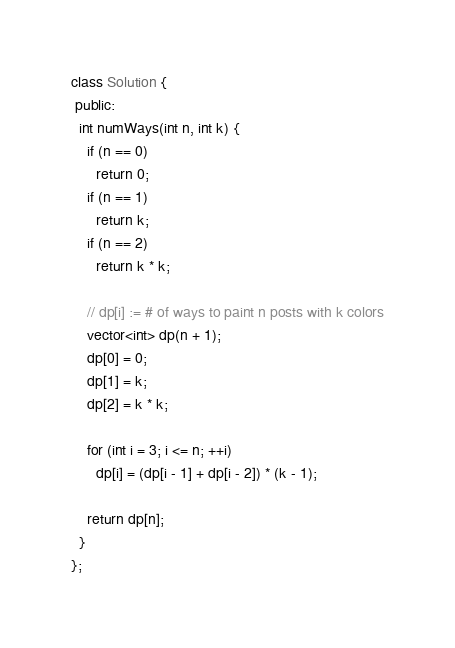<code> <loc_0><loc_0><loc_500><loc_500><_C++_>class Solution {
 public:
  int numWays(int n, int k) {
    if (n == 0)
      return 0;
    if (n == 1)
      return k;
    if (n == 2)
      return k * k;

    // dp[i] := # of ways to paint n posts with k colors
    vector<int> dp(n + 1);
    dp[0] = 0;
    dp[1] = k;
    dp[2] = k * k;

    for (int i = 3; i <= n; ++i)
      dp[i] = (dp[i - 1] + dp[i - 2]) * (k - 1);

    return dp[n];
  }
};
</code> 